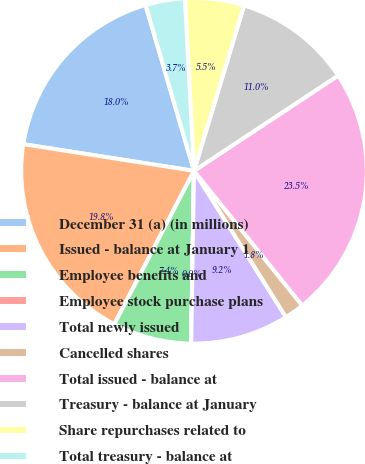Convert chart to OTSL. <chart><loc_0><loc_0><loc_500><loc_500><pie_chart><fcel>December 31 (a) (in millions)<fcel>Issued - balance at January 1<fcel>Employee benefits and<fcel>Employee stock purchase plans<fcel>Total newly issued<fcel>Cancelled shares<fcel>Total issued - balance at<fcel>Treasury - balance at January<fcel>Share repurchases related to<fcel>Total treasury - balance at<nl><fcel>18.01%<fcel>19.84%<fcel>7.36%<fcel>0.01%<fcel>9.19%<fcel>1.84%<fcel>23.52%<fcel>11.03%<fcel>5.52%<fcel>3.68%<nl></chart> 